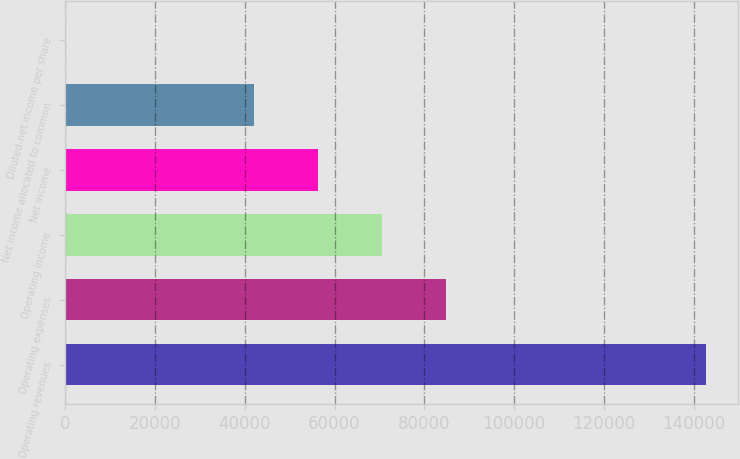Convert chart to OTSL. <chart><loc_0><loc_0><loc_500><loc_500><bar_chart><fcel>Operating revenues<fcel>Operating expenses<fcel>Operating income<fcel>Net income<fcel>Net income allocated to common<fcel>Diluted-net income per share<nl><fcel>142839<fcel>84930.6<fcel>70646.7<fcel>56362.8<fcel>42079<fcel>0.5<nl></chart> 